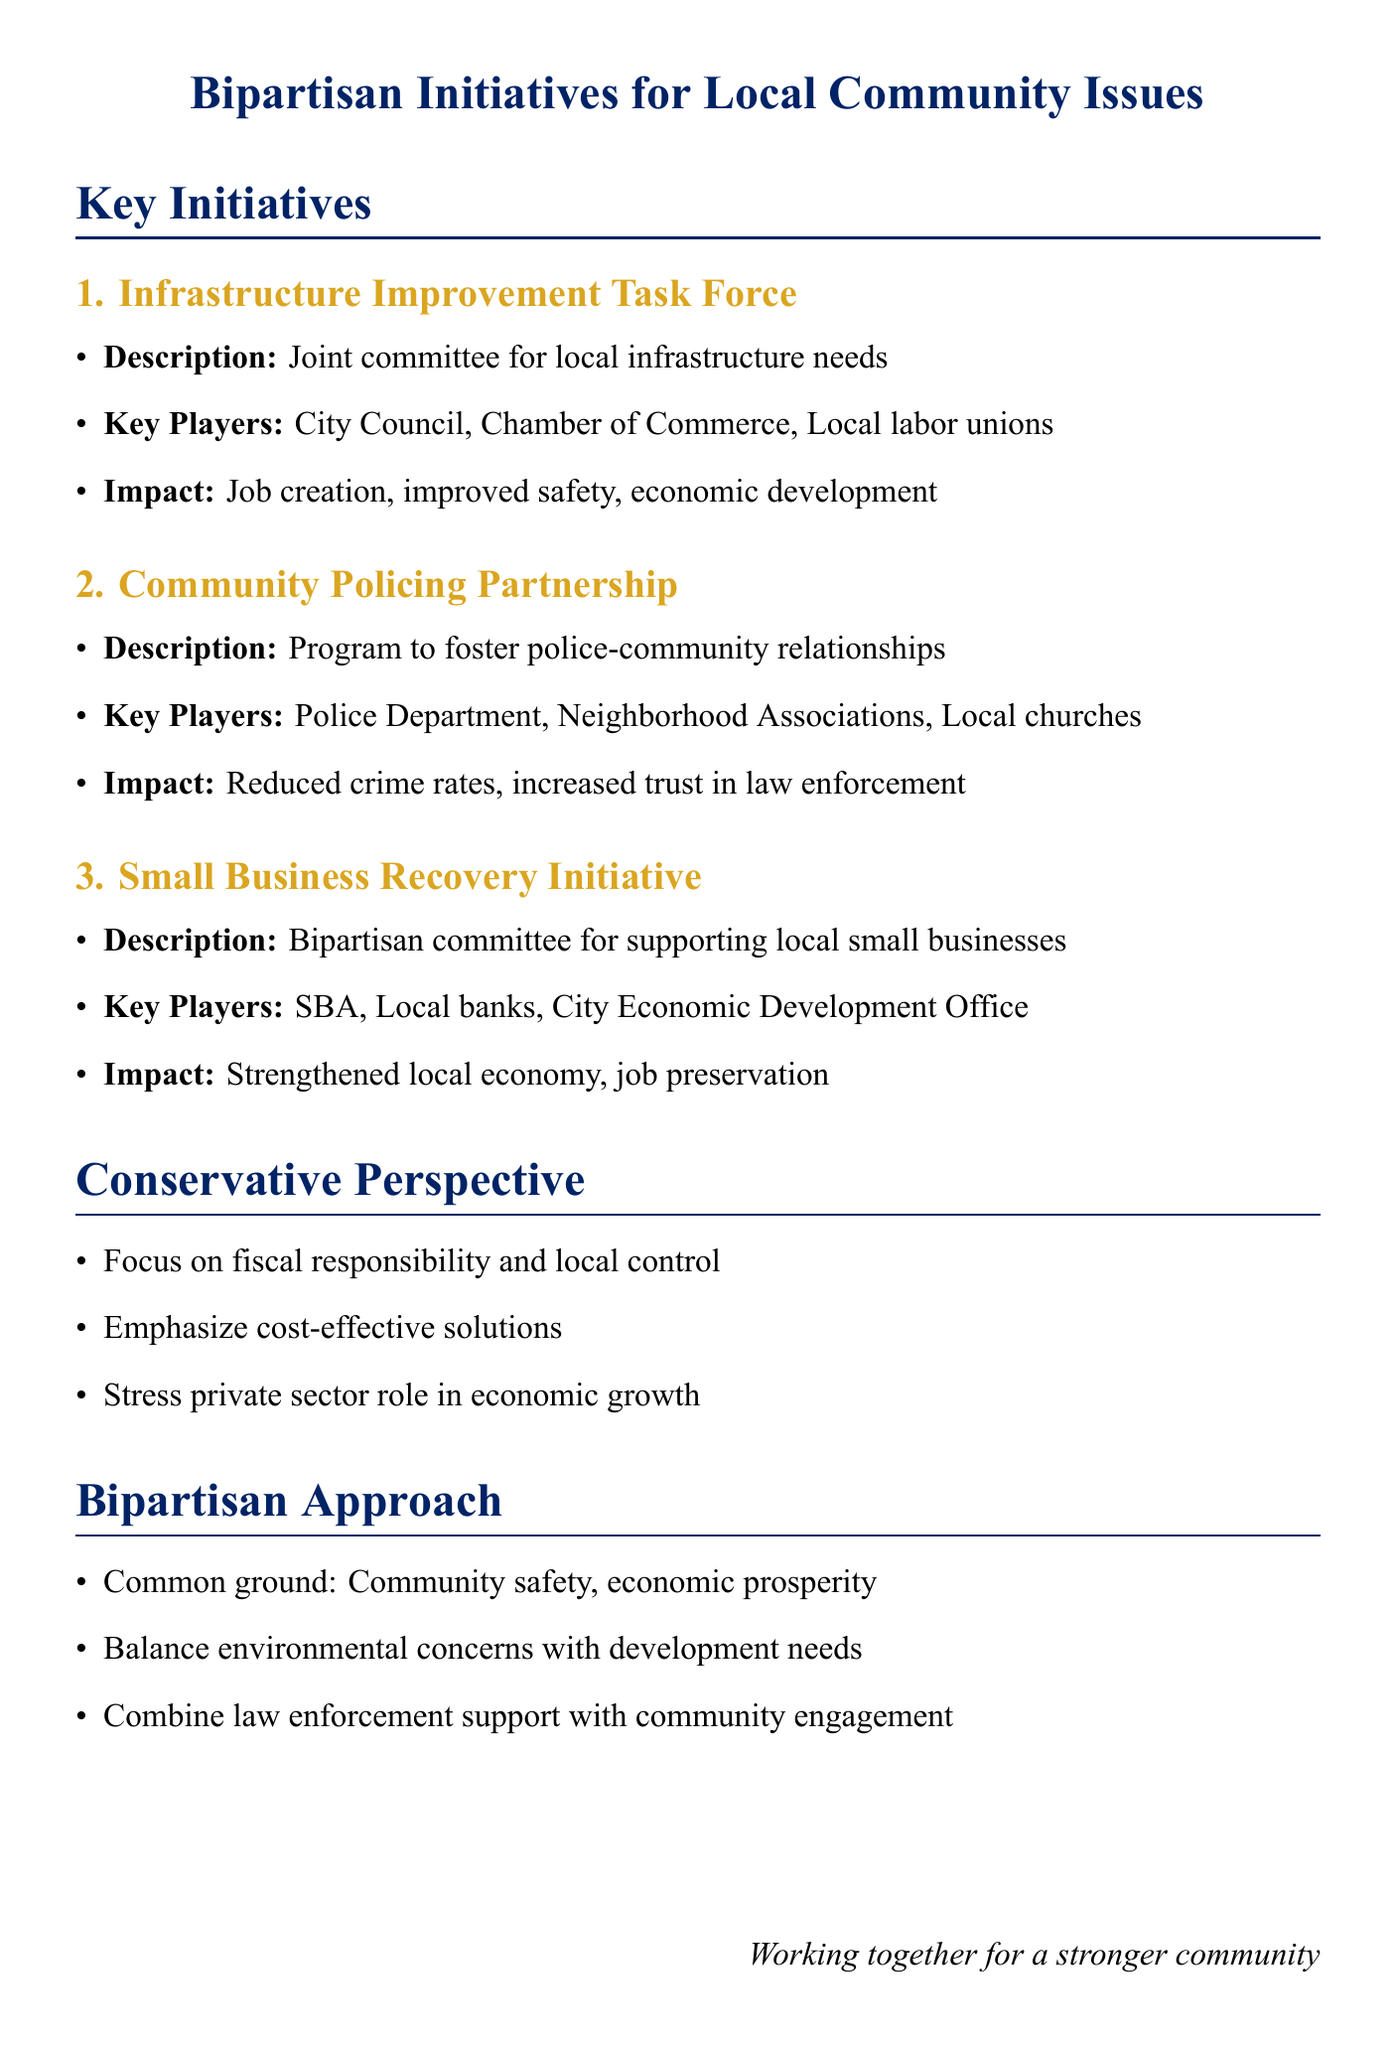What is the title of the first initiative? The title of the first initiative is presented in the document under "Key Initiatives."
Answer: Infrastructure Improvement Task Force Who are the key players in the Community Policing Partnership? Key players are identified under each initiative's description.
Answer: Police Department, Neighborhood Associations, Local churches What potential impact is highlighted for the Small Business Recovery Initiative? The potential impact is noted specifically for each initiative.
Answer: Strengthened local economy, job preservation What is a common ground focus in the bipartisan approach? Common ground focuses are listed in the "Bipartisan Approach" section.
Answer: Community safety, Economic prosperity, Quality of life improvements What type of committee is proposed for the Infrastructure Improvement Task Force? The document specifies the type of committee being formed for the initiative.
Answer: Joint committee What is the main emphasis of the conservative perspective? The main emphasis is listed in the "Conservative Perspective" section of the document.
Answer: Fiscal responsibility, Local control, Public-private partnerships How many initiatives are listed under "Key Initiatives"? The number of initiatives can be counted from the section title.
Answer: Five What strategy is proposed to balance environmental concerns? The proposal related to environmental concerns is highlighted under "Compromise strategies."
Answer: Balance environmental concerns with development needs What is the goal of the Youth Mentorship and Skills Program? The goal is mentioned in the description of that initiative.
Answer: Provide mentorship and vocational training for at-risk youth 